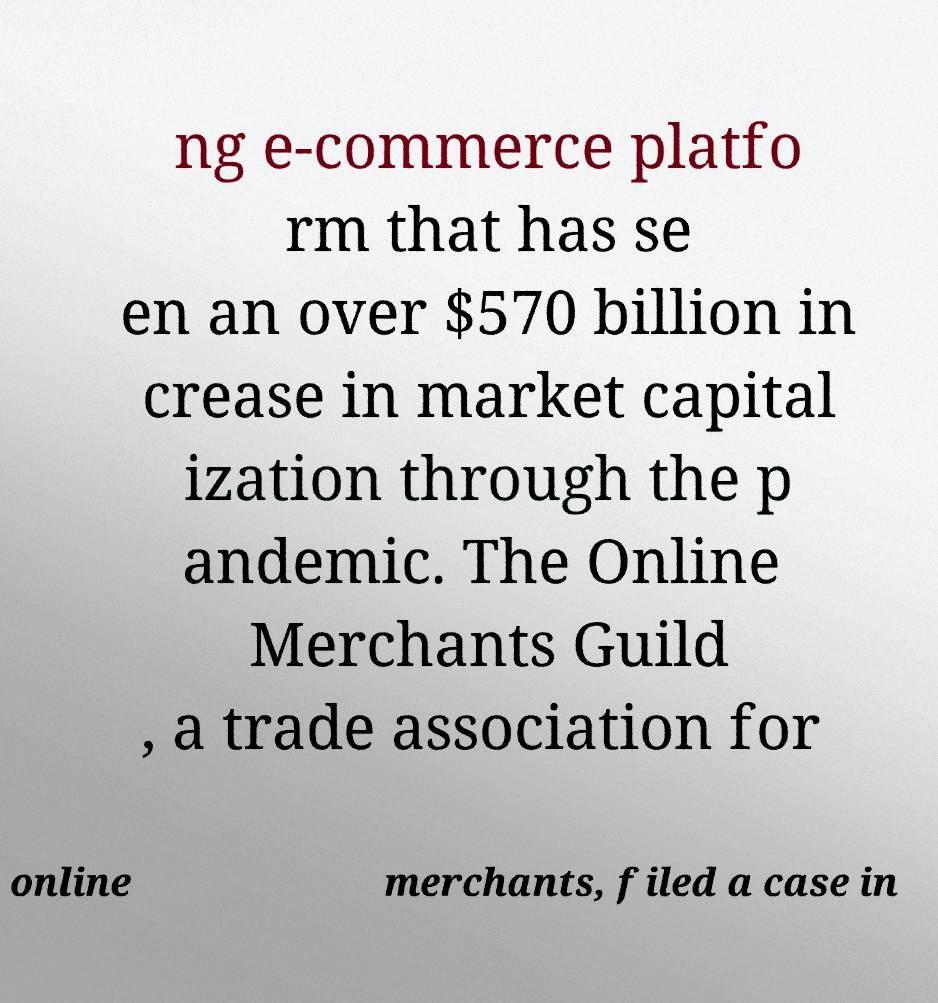Can you read and provide the text displayed in the image?This photo seems to have some interesting text. Can you extract and type it out for me? ng e-commerce platfo rm that has se en an over $570 billion in crease in market capital ization through the p andemic. The Online Merchants Guild , a trade association for online merchants, filed a case in 